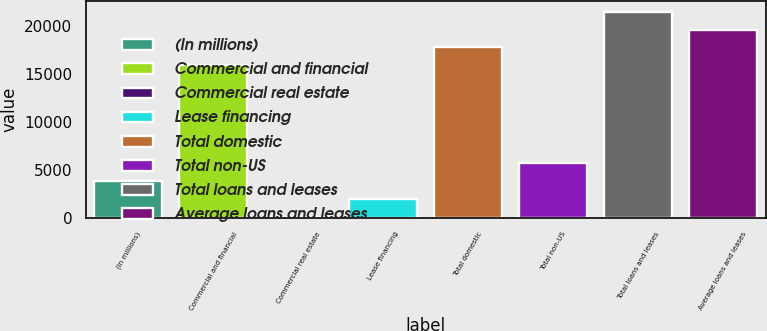Convert chart. <chart><loc_0><loc_0><loc_500><loc_500><bar_chart><fcel>(In millions)<fcel>Commercial and financial<fcel>Commercial real estate<fcel>Lease financing<fcel>Total domestic<fcel>Total non-US<fcel>Total loans and leases<fcel>Average loans and leases<nl><fcel>3782.2<fcel>15899<fcel>28<fcel>1905.1<fcel>17776.1<fcel>5659.3<fcel>21530.3<fcel>19653.2<nl></chart> 